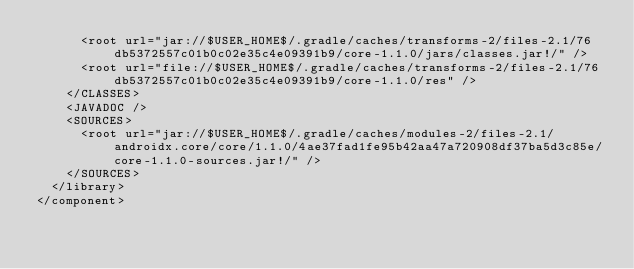Convert code to text. <code><loc_0><loc_0><loc_500><loc_500><_XML_>      <root url="jar://$USER_HOME$/.gradle/caches/transforms-2/files-2.1/76db5372557c01b0c02e35c4e09391b9/core-1.1.0/jars/classes.jar!/" />
      <root url="file://$USER_HOME$/.gradle/caches/transforms-2/files-2.1/76db5372557c01b0c02e35c4e09391b9/core-1.1.0/res" />
    </CLASSES>
    <JAVADOC />
    <SOURCES>
      <root url="jar://$USER_HOME$/.gradle/caches/modules-2/files-2.1/androidx.core/core/1.1.0/4ae37fad1fe95b42aa47a720908df37ba5d3c85e/core-1.1.0-sources.jar!/" />
    </SOURCES>
  </library>
</component></code> 